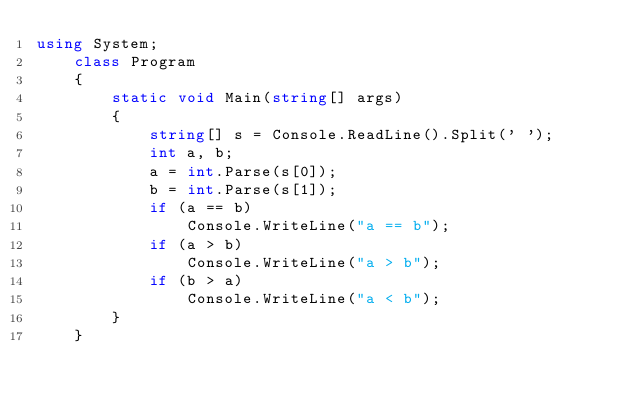Convert code to text. <code><loc_0><loc_0><loc_500><loc_500><_C#_>using System;
    class Program
    {
        static void Main(string[] args)
        {
            string[] s = Console.ReadLine().Split(' ');
            int a, b;
            a = int.Parse(s[0]);
            b = int.Parse(s[1]);
            if (a == b)
                Console.WriteLine("a == b");
            if (a > b)
                Console.WriteLine("a > b");
            if (b > a)
                Console.WriteLine("a < b");
        }
    }</code> 